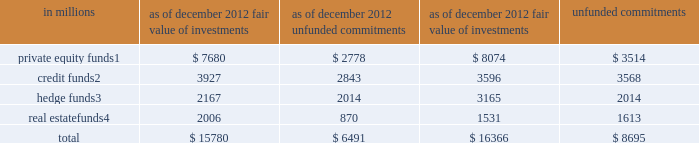Notes to consolidated financial statements investments in funds that calculate net asset value per share cash instruments at fair value include investments in funds that are valued based on the net asset value per share ( nav ) of the investment fund .
The firm uses nav as its measure of fair value for fund investments when ( i ) the fund investment does not have a readily determinable fair value and ( ii ) the nav of the investment fund is calculated in a manner consistent with the measurement principles of investment company accounting , including measurement of the underlying investments at fair value .
The firm 2019s investments in funds that calculate nav primarily consist of investments in firm-sponsored funds where the firm co-invests with third-party investors .
The private equity , credit and real estate funds are primarily closed-end funds in which the firm 2019s investments are not eligible for redemption .
Distributions will be received from these funds as the underlying assets are liquidated and it is estimated that substantially all of the underlying assets of existing funds will be liquidated over the next seven years .
The firm continues to manage its existing funds taking into account the transition periods under the volcker rule of the u.s .
Dodd-frank wall street reform and consumer protection act ( dodd-frank act ) , although the rules have not yet been finalized .
The firm 2019s investments in hedge funds are generally redeemable on a quarterly basis with 91 days 2019 notice , subject to a maximum redemption level of 25% ( 25 % ) of the firm 2019s initial investments at any quarter-end .
The firm currently plans to comply with the volcker rule by redeeming certain of its interests in hedge funds .
The firm redeemed approximately $ 1.06 billion of these interests in hedge funds during the year ended december 2012 .
The table below presents the fair value of the firm 2019s investments in , and unfunded commitments to , funds that calculate nav. .
These funds primarily invest in a broad range of industries worldwide in a variety of situations , including leveraged buyouts , recapitalizations and growth investments .
These funds generally invest in loans and other fixed income instruments and are focused on providing private high-yield capital for mid- to large-sized leveraged and management buyout transactions , recapitalizations , financings , refinancings , acquisitions and restructurings for private equity firms , private family companies and corporate issuers .
These funds are primarily multi-disciplinary hedge funds that employ a fundamental bottom-up investment approach across various asset classes and strategies including long/short equity , credit , convertibles , risk arbitrage , special situations and capital structure arbitrage .
These funds invest globally , primarily in real estate companies , loan portfolios , debt recapitalizations and direct property .
Goldman sachs 2012 annual report 127 .
What is the growth rate in the fair value of private equity funds in 2012? 
Computations: ((7680 - 8074) / 8074)
Answer: -0.0488. 